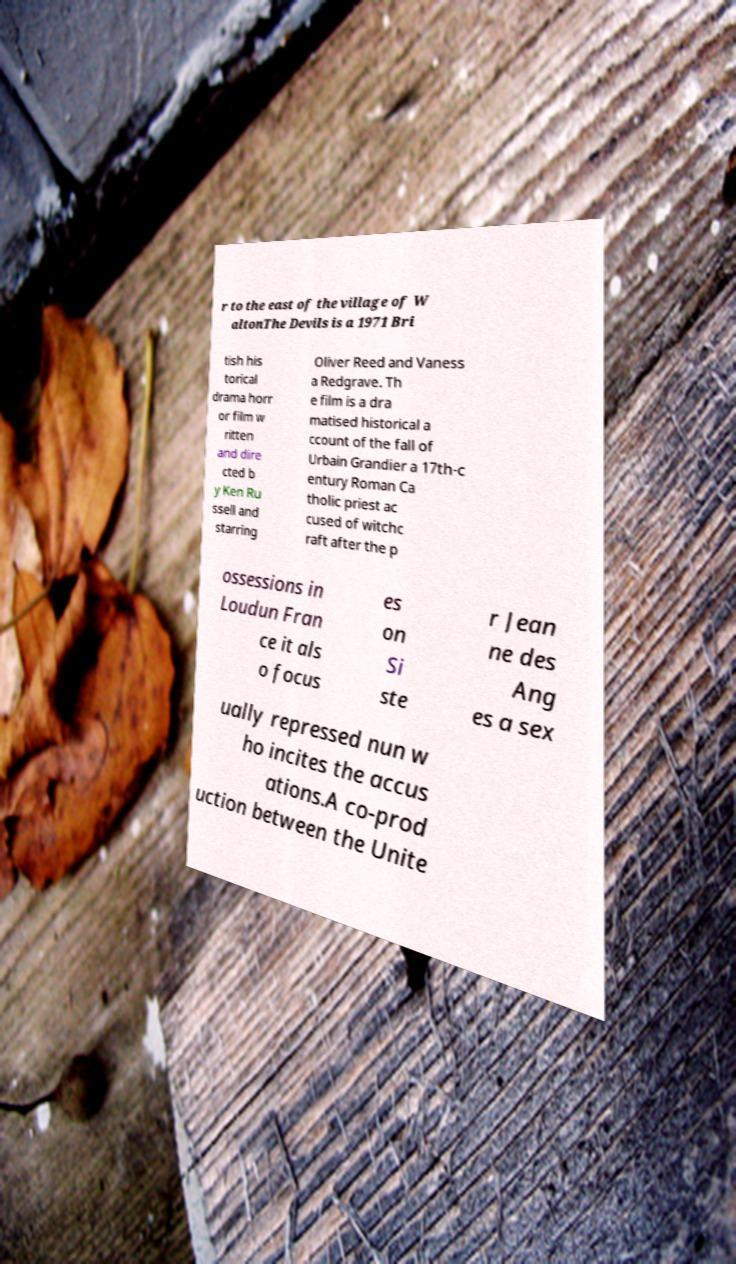I need the written content from this picture converted into text. Can you do that? r to the east of the village of W altonThe Devils is a 1971 Bri tish his torical drama horr or film w ritten and dire cted b y Ken Ru ssell and starring Oliver Reed and Vaness a Redgrave. Th e film is a dra matised historical a ccount of the fall of Urbain Grandier a 17th-c entury Roman Ca tholic priest ac cused of witchc raft after the p ossessions in Loudun Fran ce it als o focus es on Si ste r Jean ne des Ang es a sex ually repressed nun w ho incites the accus ations.A co-prod uction between the Unite 